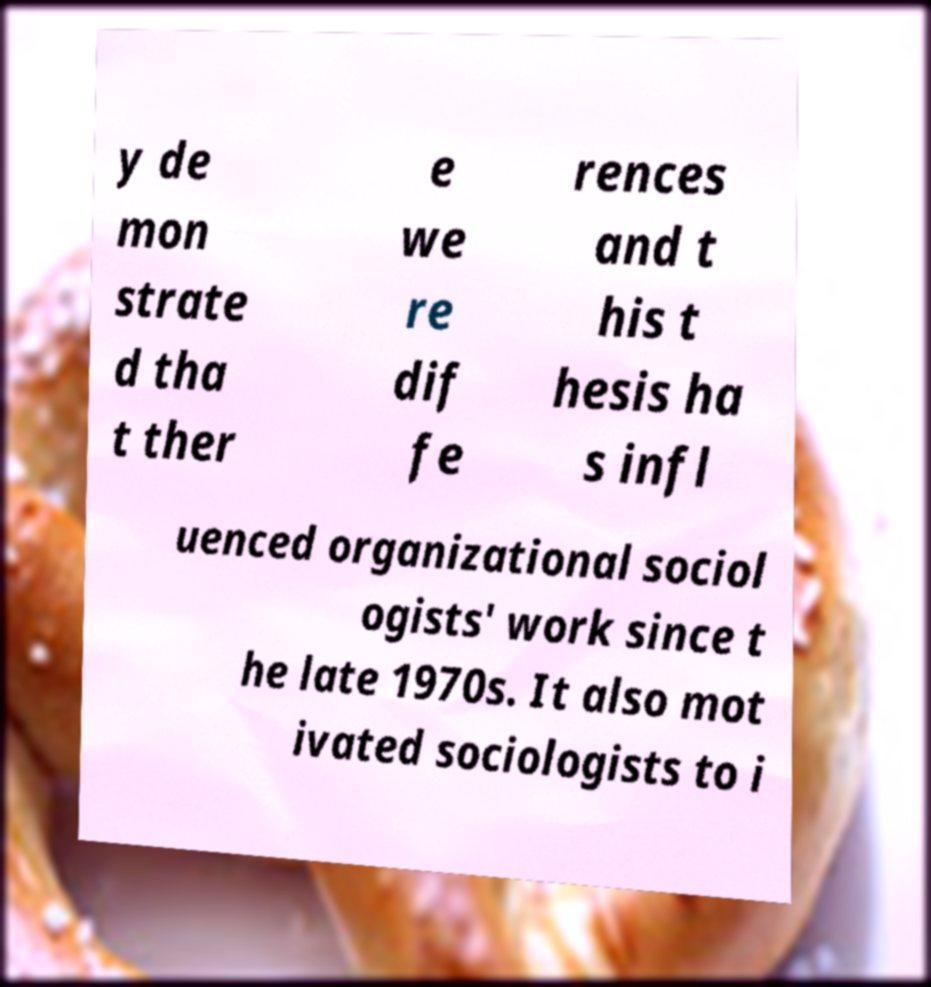There's text embedded in this image that I need extracted. Can you transcribe it verbatim? y de mon strate d tha t ther e we re dif fe rences and t his t hesis ha s infl uenced organizational sociol ogists' work since t he late 1970s. It also mot ivated sociologists to i 